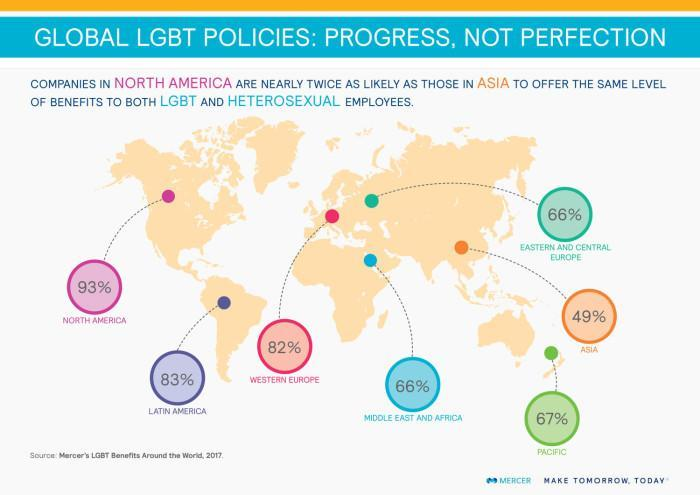What percentage of companies in Middle east & Africa offer the same level of benefits to both LGBT and Heterosexual employees?
Answer the question with a short phrase. 66% What percentage of companies in Asia offer the the same level of benefits to both LGBT and Heterosexual employees? 49% What percentage of companies in Western Europe offer the same level of benefits to both LGBT and Heterosexual employees? 82% 